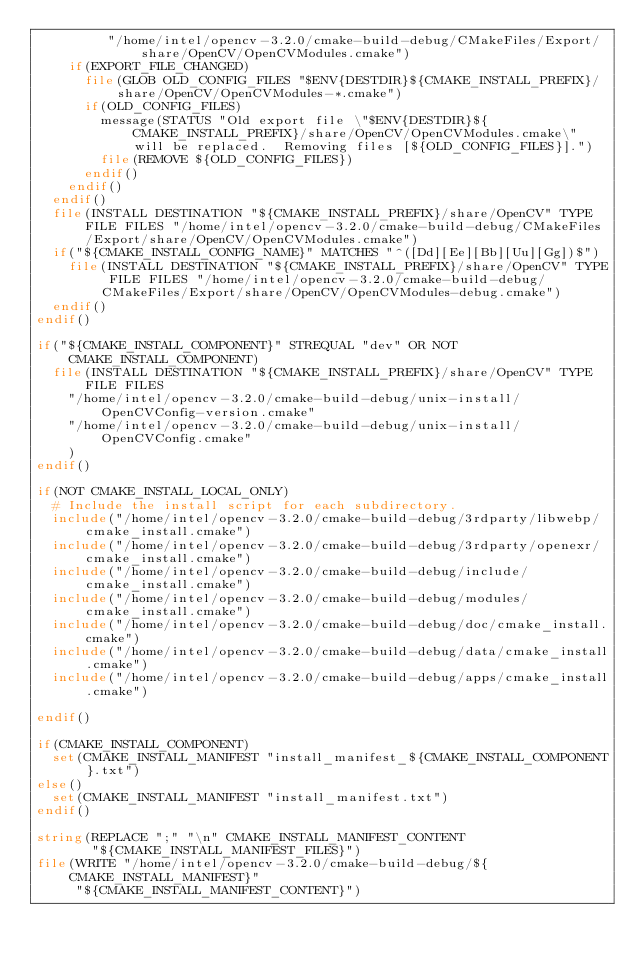Convert code to text. <code><loc_0><loc_0><loc_500><loc_500><_CMake_>         "/home/intel/opencv-3.2.0/cmake-build-debug/CMakeFiles/Export/share/OpenCV/OpenCVModules.cmake")
    if(EXPORT_FILE_CHANGED)
      file(GLOB OLD_CONFIG_FILES "$ENV{DESTDIR}${CMAKE_INSTALL_PREFIX}/share/OpenCV/OpenCVModules-*.cmake")
      if(OLD_CONFIG_FILES)
        message(STATUS "Old export file \"$ENV{DESTDIR}${CMAKE_INSTALL_PREFIX}/share/OpenCV/OpenCVModules.cmake\" will be replaced.  Removing files [${OLD_CONFIG_FILES}].")
        file(REMOVE ${OLD_CONFIG_FILES})
      endif()
    endif()
  endif()
  file(INSTALL DESTINATION "${CMAKE_INSTALL_PREFIX}/share/OpenCV" TYPE FILE FILES "/home/intel/opencv-3.2.0/cmake-build-debug/CMakeFiles/Export/share/OpenCV/OpenCVModules.cmake")
  if("${CMAKE_INSTALL_CONFIG_NAME}" MATCHES "^([Dd][Ee][Bb][Uu][Gg])$")
    file(INSTALL DESTINATION "${CMAKE_INSTALL_PREFIX}/share/OpenCV" TYPE FILE FILES "/home/intel/opencv-3.2.0/cmake-build-debug/CMakeFiles/Export/share/OpenCV/OpenCVModules-debug.cmake")
  endif()
endif()

if("${CMAKE_INSTALL_COMPONENT}" STREQUAL "dev" OR NOT CMAKE_INSTALL_COMPONENT)
  file(INSTALL DESTINATION "${CMAKE_INSTALL_PREFIX}/share/OpenCV" TYPE FILE FILES
    "/home/intel/opencv-3.2.0/cmake-build-debug/unix-install/OpenCVConfig-version.cmake"
    "/home/intel/opencv-3.2.0/cmake-build-debug/unix-install/OpenCVConfig.cmake"
    )
endif()

if(NOT CMAKE_INSTALL_LOCAL_ONLY)
  # Include the install script for each subdirectory.
  include("/home/intel/opencv-3.2.0/cmake-build-debug/3rdparty/libwebp/cmake_install.cmake")
  include("/home/intel/opencv-3.2.0/cmake-build-debug/3rdparty/openexr/cmake_install.cmake")
  include("/home/intel/opencv-3.2.0/cmake-build-debug/include/cmake_install.cmake")
  include("/home/intel/opencv-3.2.0/cmake-build-debug/modules/cmake_install.cmake")
  include("/home/intel/opencv-3.2.0/cmake-build-debug/doc/cmake_install.cmake")
  include("/home/intel/opencv-3.2.0/cmake-build-debug/data/cmake_install.cmake")
  include("/home/intel/opencv-3.2.0/cmake-build-debug/apps/cmake_install.cmake")

endif()

if(CMAKE_INSTALL_COMPONENT)
  set(CMAKE_INSTALL_MANIFEST "install_manifest_${CMAKE_INSTALL_COMPONENT}.txt")
else()
  set(CMAKE_INSTALL_MANIFEST "install_manifest.txt")
endif()

string(REPLACE ";" "\n" CMAKE_INSTALL_MANIFEST_CONTENT
       "${CMAKE_INSTALL_MANIFEST_FILES}")
file(WRITE "/home/intel/opencv-3.2.0/cmake-build-debug/${CMAKE_INSTALL_MANIFEST}"
     "${CMAKE_INSTALL_MANIFEST_CONTENT}")
</code> 